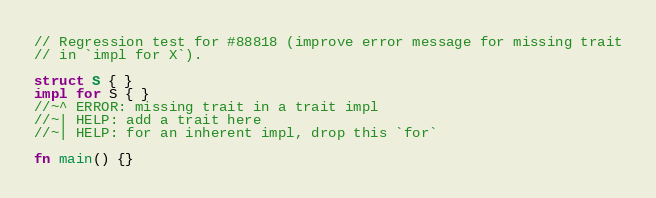<code> <loc_0><loc_0><loc_500><loc_500><_Rust_>// Regression test for #88818 (improve error message for missing trait
// in `impl for X`).

struct S { }
impl for S { }
//~^ ERROR: missing trait in a trait impl
//~| HELP: add a trait here
//~| HELP: for an inherent impl, drop this `for`

fn main() {}
</code> 